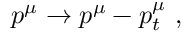Convert formula to latex. <formula><loc_0><loc_0><loc_500><loc_500>p ^ { \mu } \to p ^ { \mu } - p _ { t } ^ { \mu } \ ,</formula> 